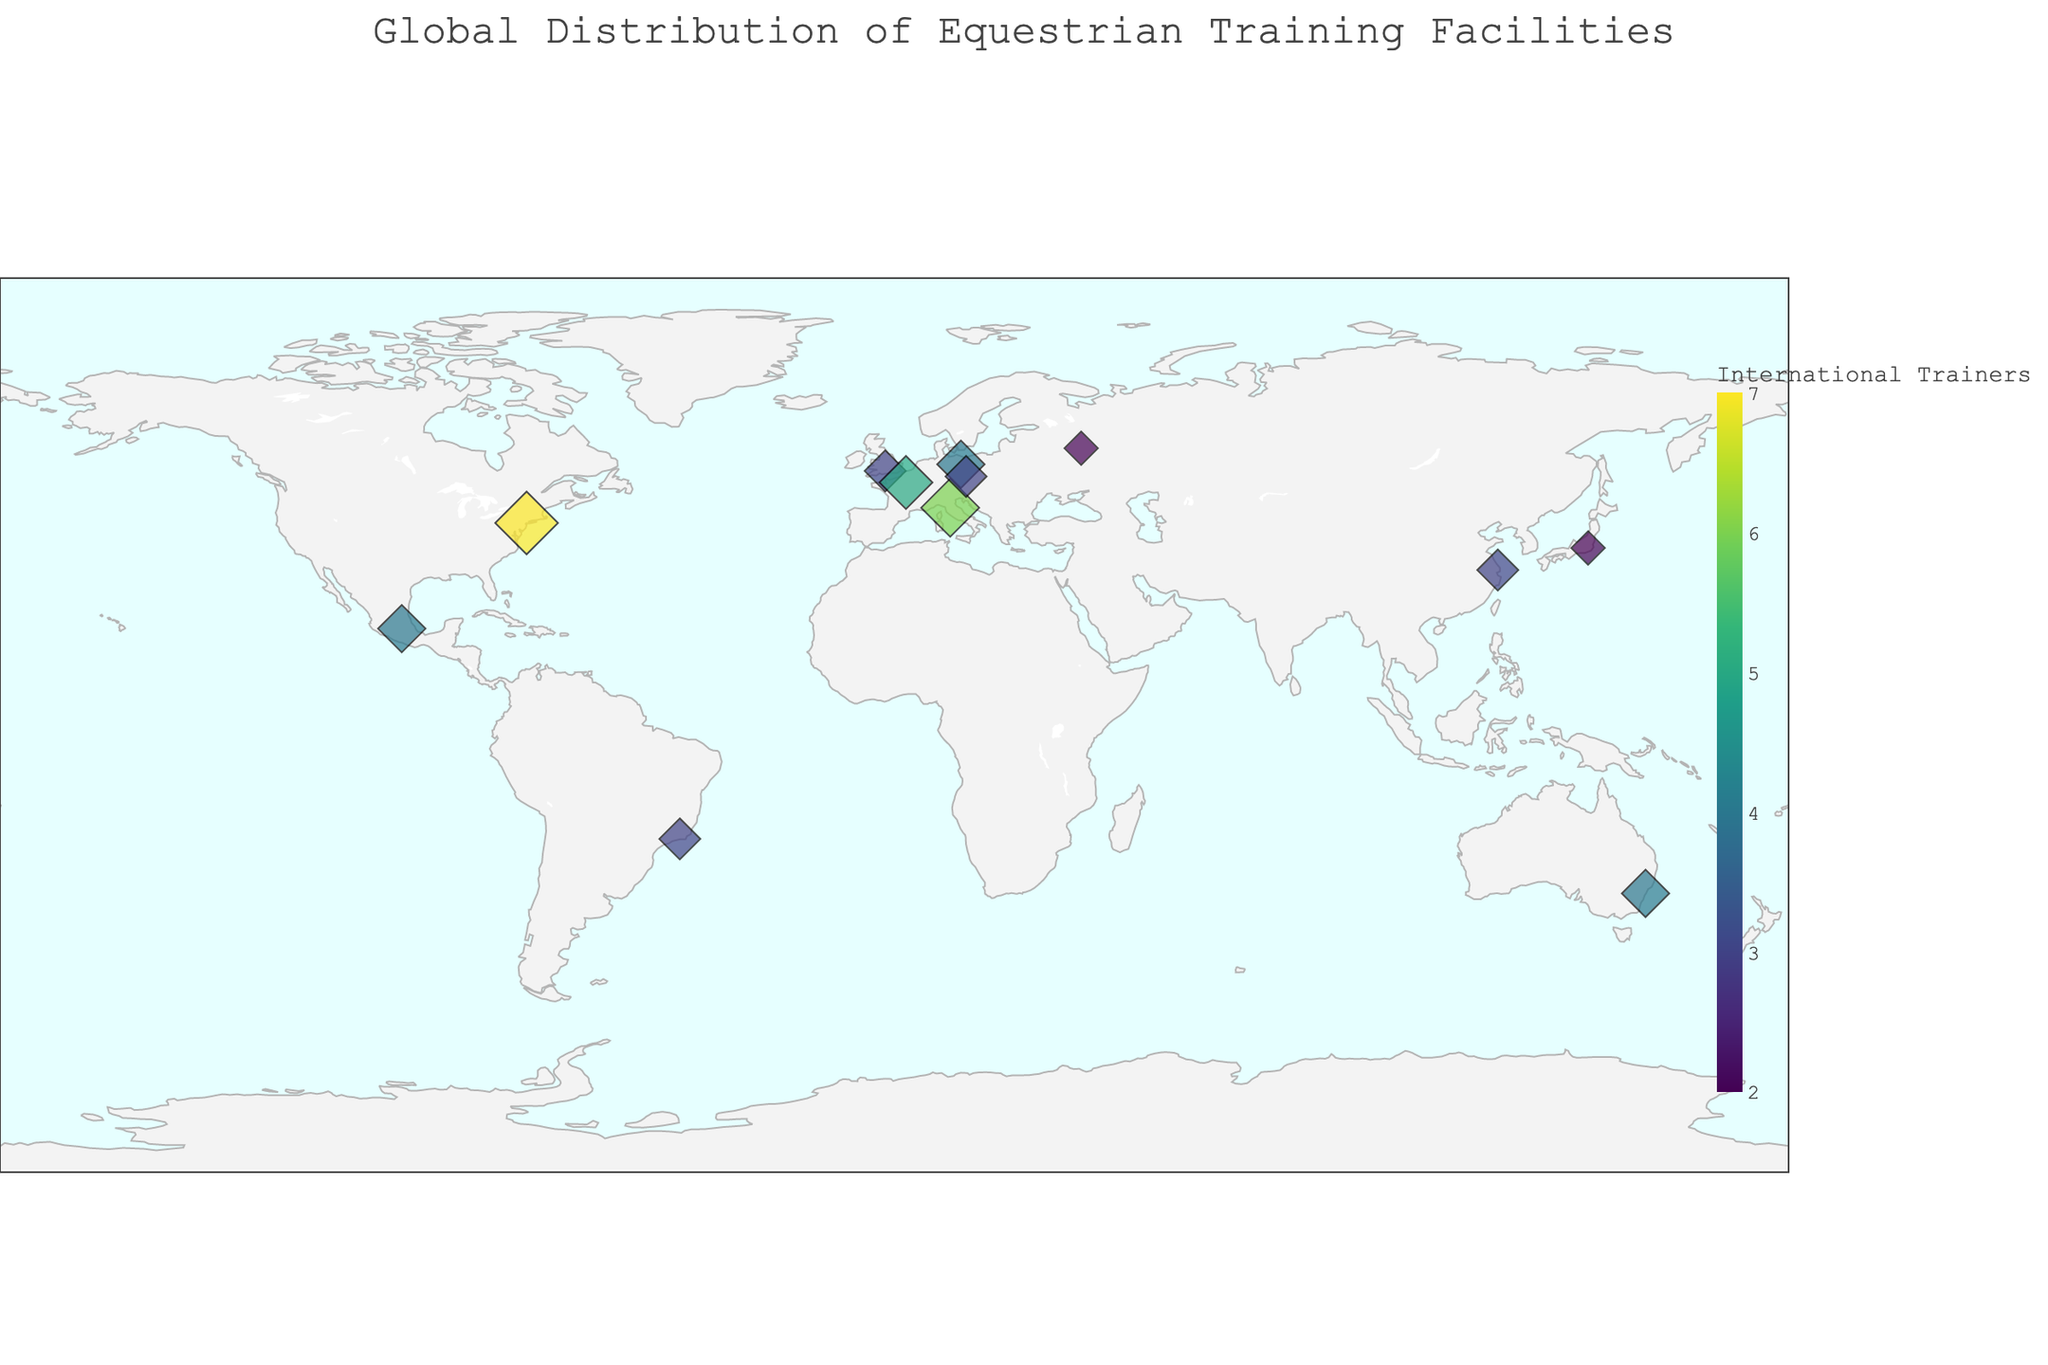How many equestrian training facilities are indicated on the map? The map contains various marked points, each representing an equestrian training facility. Counting these points gives the total number of facilities displayed.
Answer: 12 Which facility has the most international trainers? By looking at the size of the markers and hovering over the points, you can identify the Wellington Equestrian Center in the USA as having the largest circle, indicating the highest number of international trainers.
Answer: Wellington Equestrian Center What is the total number of international trainers combined from all the facilities? Sum the number of international trainers from each facility: 3+5+7+4+2+3+4+6+3+2+4+3 = 46
Answer: 46 Which two facilities have the fewest international trainers, and how many do they each have? Hovering over the points identifies the Moscow Equestrian School in Russia and Tokyo Riding Park in Japan as the smallest circles, both with 2 international trainers.
Answer: Moscow Equestrian School and Tokyo Riding Park; 2 each Which country has the highest number of international equestrian trainers? By summing the number of trainers in each country: USA=7, France=5, Italy=6, etc., you find that the USA has the highest number with 7 international trainers.
Answer: USA Compare the number of international trainers between the Sydney International Equestrian Centre and Tuscany Equestrian Center. Which one has more, and by how much? The Sydney International Equestrian Centre has 4, and the Tuscany Equestrian Center has 6 international trainers. The difference is 6 - 4 = 2.
Answer: Tuscany Equestrian Center; 2 more What is the average number of international trainers per facility? Sum the total number of trainers (which is 46) and divide by the number of facilities (which is 12). So, 46 / 12 ≈ 3.83.
Answer: Approximately 3.83 Are there any facilities with an equal number of international trainers, and if so, which ones? By comparing the numbers next to the markers, you see that Tedworth Equestrian (UK), Shanghai Riding Club (China), and Rio Equestrian Center (Brazil) each have 3 trainers, as well as Sidney International Equestrian Centre (Australia) and Mexico City Equestrian Club (Mexico) each have 4 trainers.
Answer: Tedworth Equestrian, Shanghai Riding Club, Rio Equestrian Center; Sidney International Equestrian Centre, Mexico City Equestrian Club Which continent has the most facilities represented on the map? By identifying the continents for each country: UK and Germany (Europe), USA (North America), Russia (Europe/Asia), China and Japan (Asia), Australia, Italy (Europe), Czech Republic (Europe), Mexico (North America), Brazil (South America), and France (Europe). Europe has the most with 7 facilities.
Answer: Europe What is the distribution range of international trainers among the facilities? The lowest number of trainers is 2, observed in Moscow Equestrian School and Tokyo Riding Park, and the highest is 7 at Wellington Equestrian Center. The range is therefore 7 - 2 = 5.
Answer: 5 